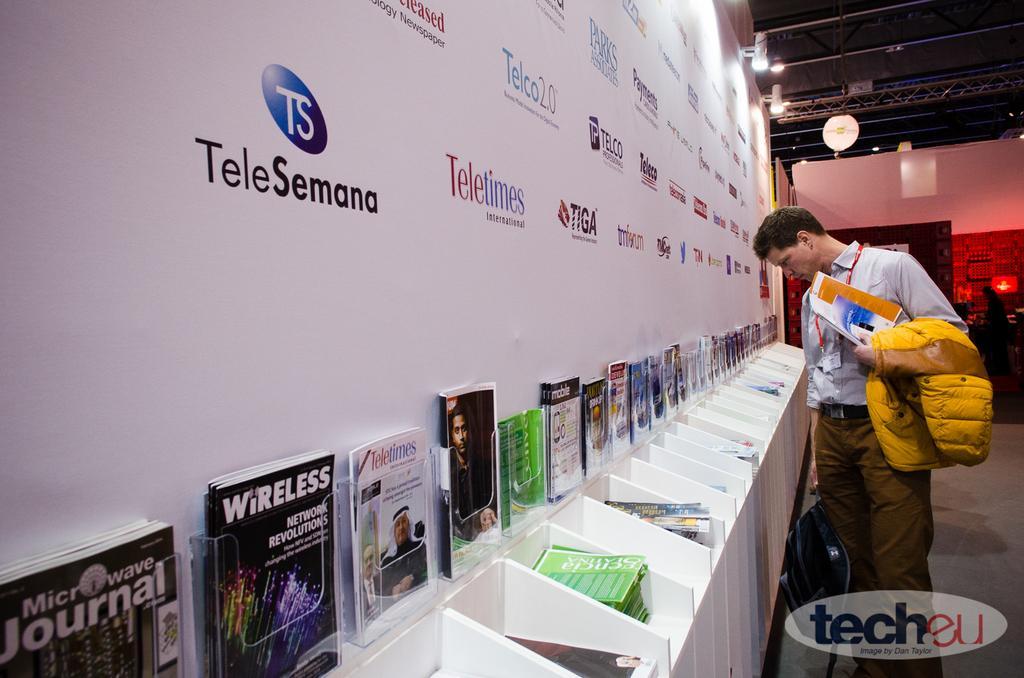Can you describe this image briefly? There is one person standing and holding a jacket and a book on the right side of this image, and there is a wall in the background. We can see there is a wall poster on the left side of this image. There are some books kept in the racks at the bottom of this image. There is a watermark at the bottom right corner of this image. There is a chair on the left side to this watermark. 